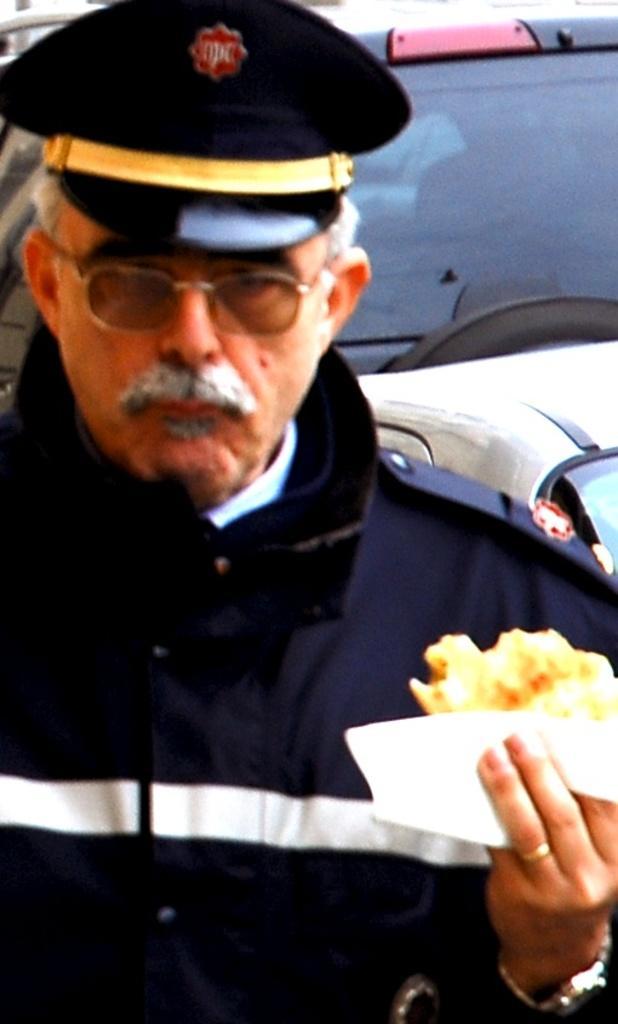Could you give a brief overview of what you see in this image? In the picture we can see a policeman holding a food item in his hand and behind him we can see a part of the vehicle with a windshield. 